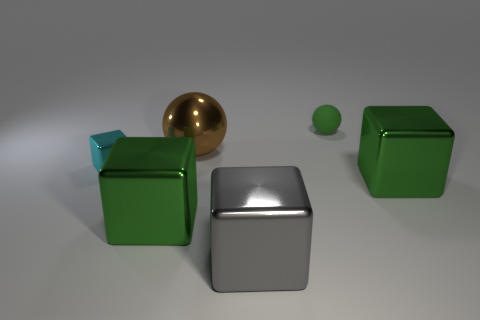Subtract all tiny cyan cubes. How many cubes are left? 3 Add 2 large cylinders. How many objects exist? 8 Subtract all brown balls. How many balls are left? 1 Subtract all balls. How many objects are left? 4 Add 6 yellow metallic blocks. How many yellow metallic blocks exist? 6 Subtract 0 blue cylinders. How many objects are left? 6 Subtract 1 cubes. How many cubes are left? 3 Subtract all red spheres. Subtract all green cylinders. How many spheres are left? 2 Subtract all red balls. How many yellow cubes are left? 0 Subtract all small blue rubber things. Subtract all gray metal cubes. How many objects are left? 5 